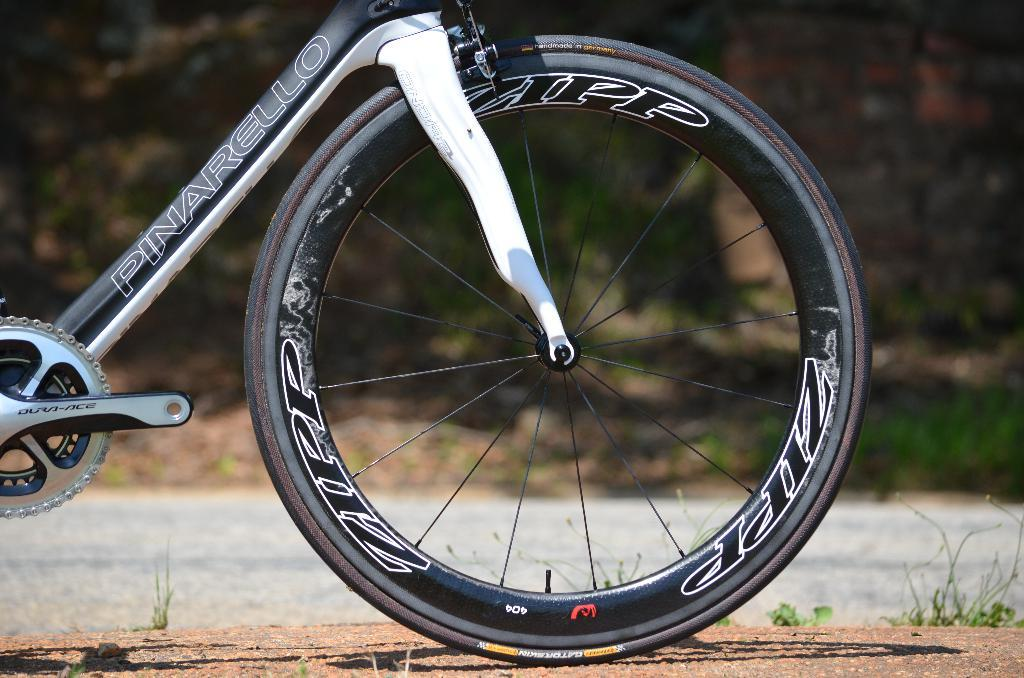What is the main object in the image? There is a bicycle in the image. Where is the bicycle located? The bicycle is on a piece of land. Can you describe the land where the bicycle is located? The land has grass and plants. What is beside the land where the bicycle is located? There is a road beside the land. What can be seen in the background of the image? There are plants in the background of the image. What type of drum can be heard playing in harmony with the bicycle in the image? There is no drum or any sound present in the image; it is a still image of a bicycle on a piece of land. 